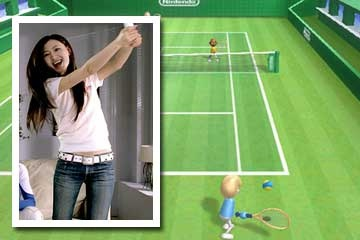Describe the objects in this image and their specific colors. I can see people in green, black, lightgray, gray, and darkgray tones, couch in green, darkgray, tan, lightgray, and gray tones, tennis racket in green, lightgreen, khaki, and blue tones, sports ball in green, teal, and khaki tones, and remote in lightgray, darkgray, green, and white tones in this image. 